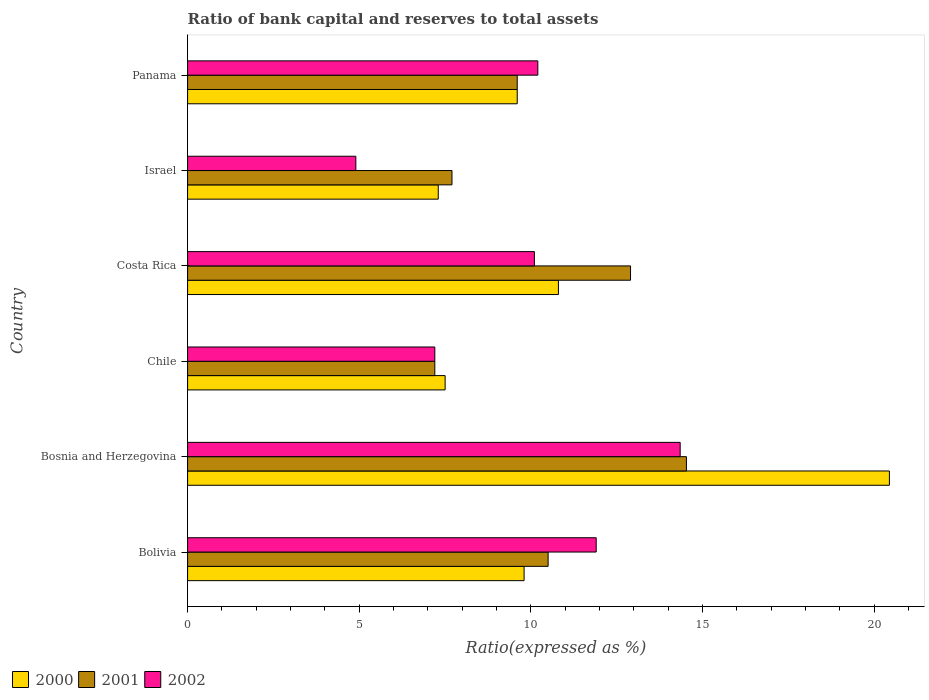Are the number of bars per tick equal to the number of legend labels?
Provide a succinct answer. Yes. How many bars are there on the 2nd tick from the top?
Offer a very short reply. 3. How many bars are there on the 5th tick from the bottom?
Offer a very short reply. 3. What is the label of the 6th group of bars from the top?
Your answer should be very brief. Bolivia. What is the ratio of bank capital and reserves to total assets in 2000 in Chile?
Make the answer very short. 7.5. Across all countries, what is the maximum ratio of bank capital and reserves to total assets in 2000?
Give a very brief answer. 20.44. In which country was the ratio of bank capital and reserves to total assets in 2001 maximum?
Provide a succinct answer. Bosnia and Herzegovina. In which country was the ratio of bank capital and reserves to total assets in 2001 minimum?
Ensure brevity in your answer.  Chile. What is the total ratio of bank capital and reserves to total assets in 2001 in the graph?
Your answer should be compact. 62.43. What is the difference between the ratio of bank capital and reserves to total assets in 2001 in Bolivia and the ratio of bank capital and reserves to total assets in 2002 in Chile?
Provide a succinct answer. 3.3. What is the average ratio of bank capital and reserves to total assets in 2000 per country?
Your response must be concise. 10.91. What is the difference between the ratio of bank capital and reserves to total assets in 2001 and ratio of bank capital and reserves to total assets in 2000 in Costa Rica?
Ensure brevity in your answer.  2.1. What is the ratio of the ratio of bank capital and reserves to total assets in 2002 in Bolivia to that in Chile?
Ensure brevity in your answer.  1.65. Is the ratio of bank capital and reserves to total assets in 2000 in Chile less than that in Panama?
Make the answer very short. Yes. What is the difference between the highest and the second highest ratio of bank capital and reserves to total assets in 2002?
Your answer should be compact. 2.45. What is the difference between the highest and the lowest ratio of bank capital and reserves to total assets in 2002?
Ensure brevity in your answer.  9.45. In how many countries, is the ratio of bank capital and reserves to total assets in 2000 greater than the average ratio of bank capital and reserves to total assets in 2000 taken over all countries?
Give a very brief answer. 1. Is the sum of the ratio of bank capital and reserves to total assets in 2001 in Chile and Costa Rica greater than the maximum ratio of bank capital and reserves to total assets in 2002 across all countries?
Give a very brief answer. Yes. What does the 3rd bar from the bottom in Panama represents?
Provide a succinct answer. 2002. Are all the bars in the graph horizontal?
Your answer should be very brief. Yes. How many countries are there in the graph?
Provide a succinct answer. 6. Are the values on the major ticks of X-axis written in scientific E-notation?
Give a very brief answer. No. Does the graph contain any zero values?
Provide a succinct answer. No. How are the legend labels stacked?
Provide a succinct answer. Horizontal. What is the title of the graph?
Provide a short and direct response. Ratio of bank capital and reserves to total assets. What is the label or title of the X-axis?
Your response must be concise. Ratio(expressed as %). What is the Ratio(expressed as %) in 2000 in Bolivia?
Offer a very short reply. 9.8. What is the Ratio(expressed as %) of 2001 in Bolivia?
Keep it short and to the point. 10.5. What is the Ratio(expressed as %) of 2002 in Bolivia?
Make the answer very short. 11.9. What is the Ratio(expressed as %) in 2000 in Bosnia and Herzegovina?
Ensure brevity in your answer.  20.44. What is the Ratio(expressed as %) in 2001 in Bosnia and Herzegovina?
Keep it short and to the point. 14.53. What is the Ratio(expressed as %) in 2002 in Bosnia and Herzegovina?
Your answer should be compact. 14.35. What is the Ratio(expressed as %) in 2002 in Chile?
Make the answer very short. 7.2. What is the Ratio(expressed as %) in 2000 in Costa Rica?
Your answer should be very brief. 10.8. What is the Ratio(expressed as %) of 2001 in Costa Rica?
Provide a succinct answer. 12.9. What is the Ratio(expressed as %) in 2000 in Israel?
Your response must be concise. 7.3. What is the Ratio(expressed as %) of 2000 in Panama?
Offer a terse response. 9.6. What is the Ratio(expressed as %) in 2001 in Panama?
Offer a very short reply. 9.6. What is the Ratio(expressed as %) in 2002 in Panama?
Your response must be concise. 10.2. Across all countries, what is the maximum Ratio(expressed as %) of 2000?
Provide a succinct answer. 20.44. Across all countries, what is the maximum Ratio(expressed as %) in 2001?
Offer a terse response. 14.53. Across all countries, what is the maximum Ratio(expressed as %) of 2002?
Make the answer very short. 14.35. Across all countries, what is the minimum Ratio(expressed as %) of 2000?
Offer a very short reply. 7.3. Across all countries, what is the minimum Ratio(expressed as %) in 2001?
Provide a short and direct response. 7.2. Across all countries, what is the minimum Ratio(expressed as %) of 2002?
Your answer should be very brief. 4.9. What is the total Ratio(expressed as %) of 2000 in the graph?
Your response must be concise. 65.44. What is the total Ratio(expressed as %) in 2001 in the graph?
Give a very brief answer. 62.43. What is the total Ratio(expressed as %) of 2002 in the graph?
Make the answer very short. 58.65. What is the difference between the Ratio(expressed as %) in 2000 in Bolivia and that in Bosnia and Herzegovina?
Keep it short and to the point. -10.64. What is the difference between the Ratio(expressed as %) in 2001 in Bolivia and that in Bosnia and Herzegovina?
Ensure brevity in your answer.  -4.03. What is the difference between the Ratio(expressed as %) in 2002 in Bolivia and that in Bosnia and Herzegovina?
Make the answer very short. -2.45. What is the difference between the Ratio(expressed as %) of 2000 in Bolivia and that in Chile?
Offer a terse response. 2.3. What is the difference between the Ratio(expressed as %) of 2000 in Bolivia and that in Costa Rica?
Keep it short and to the point. -1. What is the difference between the Ratio(expressed as %) in 2000 in Bolivia and that in Israel?
Your answer should be very brief. 2.5. What is the difference between the Ratio(expressed as %) of 2000 in Bolivia and that in Panama?
Offer a terse response. 0.2. What is the difference between the Ratio(expressed as %) of 2001 in Bolivia and that in Panama?
Offer a very short reply. 0.9. What is the difference between the Ratio(expressed as %) in 2002 in Bolivia and that in Panama?
Keep it short and to the point. 1.7. What is the difference between the Ratio(expressed as %) in 2000 in Bosnia and Herzegovina and that in Chile?
Make the answer very short. 12.94. What is the difference between the Ratio(expressed as %) in 2001 in Bosnia and Herzegovina and that in Chile?
Your answer should be compact. 7.33. What is the difference between the Ratio(expressed as %) of 2002 in Bosnia and Herzegovina and that in Chile?
Your response must be concise. 7.15. What is the difference between the Ratio(expressed as %) in 2000 in Bosnia and Herzegovina and that in Costa Rica?
Ensure brevity in your answer.  9.64. What is the difference between the Ratio(expressed as %) of 2001 in Bosnia and Herzegovina and that in Costa Rica?
Offer a terse response. 1.63. What is the difference between the Ratio(expressed as %) in 2002 in Bosnia and Herzegovina and that in Costa Rica?
Your response must be concise. 4.25. What is the difference between the Ratio(expressed as %) in 2000 in Bosnia and Herzegovina and that in Israel?
Offer a very short reply. 13.14. What is the difference between the Ratio(expressed as %) of 2001 in Bosnia and Herzegovina and that in Israel?
Offer a very short reply. 6.83. What is the difference between the Ratio(expressed as %) in 2002 in Bosnia and Herzegovina and that in Israel?
Your answer should be very brief. 9.45. What is the difference between the Ratio(expressed as %) in 2000 in Bosnia and Herzegovina and that in Panama?
Provide a succinct answer. 10.84. What is the difference between the Ratio(expressed as %) of 2001 in Bosnia and Herzegovina and that in Panama?
Provide a short and direct response. 4.93. What is the difference between the Ratio(expressed as %) in 2002 in Bosnia and Herzegovina and that in Panama?
Ensure brevity in your answer.  4.15. What is the difference between the Ratio(expressed as %) in 2000 in Chile and that in Costa Rica?
Your response must be concise. -3.3. What is the difference between the Ratio(expressed as %) in 2000 in Chile and that in Panama?
Give a very brief answer. -2.1. What is the difference between the Ratio(expressed as %) of 2001 in Chile and that in Panama?
Make the answer very short. -2.4. What is the difference between the Ratio(expressed as %) of 2002 in Chile and that in Panama?
Ensure brevity in your answer.  -3. What is the difference between the Ratio(expressed as %) of 2000 in Israel and that in Panama?
Make the answer very short. -2.3. What is the difference between the Ratio(expressed as %) in 2001 in Israel and that in Panama?
Your answer should be compact. -1.9. What is the difference between the Ratio(expressed as %) of 2002 in Israel and that in Panama?
Provide a short and direct response. -5.3. What is the difference between the Ratio(expressed as %) of 2000 in Bolivia and the Ratio(expressed as %) of 2001 in Bosnia and Herzegovina?
Make the answer very short. -4.73. What is the difference between the Ratio(expressed as %) of 2000 in Bolivia and the Ratio(expressed as %) of 2002 in Bosnia and Herzegovina?
Keep it short and to the point. -4.55. What is the difference between the Ratio(expressed as %) of 2001 in Bolivia and the Ratio(expressed as %) of 2002 in Bosnia and Herzegovina?
Make the answer very short. -3.85. What is the difference between the Ratio(expressed as %) of 2000 in Bolivia and the Ratio(expressed as %) of 2001 in Chile?
Ensure brevity in your answer.  2.6. What is the difference between the Ratio(expressed as %) of 2001 in Bolivia and the Ratio(expressed as %) of 2002 in Chile?
Keep it short and to the point. 3.3. What is the difference between the Ratio(expressed as %) of 2000 in Bolivia and the Ratio(expressed as %) of 2002 in Costa Rica?
Provide a short and direct response. -0.3. What is the difference between the Ratio(expressed as %) of 2001 in Bolivia and the Ratio(expressed as %) of 2002 in Costa Rica?
Your response must be concise. 0.4. What is the difference between the Ratio(expressed as %) of 2000 in Bolivia and the Ratio(expressed as %) of 2001 in Israel?
Offer a terse response. 2.1. What is the difference between the Ratio(expressed as %) in 2001 in Bolivia and the Ratio(expressed as %) in 2002 in Panama?
Provide a short and direct response. 0.3. What is the difference between the Ratio(expressed as %) in 2000 in Bosnia and Herzegovina and the Ratio(expressed as %) in 2001 in Chile?
Your answer should be very brief. 13.24. What is the difference between the Ratio(expressed as %) in 2000 in Bosnia and Herzegovina and the Ratio(expressed as %) in 2002 in Chile?
Your response must be concise. 13.24. What is the difference between the Ratio(expressed as %) of 2001 in Bosnia and Herzegovina and the Ratio(expressed as %) of 2002 in Chile?
Offer a terse response. 7.33. What is the difference between the Ratio(expressed as %) in 2000 in Bosnia and Herzegovina and the Ratio(expressed as %) in 2001 in Costa Rica?
Provide a short and direct response. 7.54. What is the difference between the Ratio(expressed as %) of 2000 in Bosnia and Herzegovina and the Ratio(expressed as %) of 2002 in Costa Rica?
Keep it short and to the point. 10.34. What is the difference between the Ratio(expressed as %) in 2001 in Bosnia and Herzegovina and the Ratio(expressed as %) in 2002 in Costa Rica?
Your response must be concise. 4.43. What is the difference between the Ratio(expressed as %) of 2000 in Bosnia and Herzegovina and the Ratio(expressed as %) of 2001 in Israel?
Ensure brevity in your answer.  12.74. What is the difference between the Ratio(expressed as %) in 2000 in Bosnia and Herzegovina and the Ratio(expressed as %) in 2002 in Israel?
Offer a very short reply. 15.54. What is the difference between the Ratio(expressed as %) in 2001 in Bosnia and Herzegovina and the Ratio(expressed as %) in 2002 in Israel?
Ensure brevity in your answer.  9.63. What is the difference between the Ratio(expressed as %) of 2000 in Bosnia and Herzegovina and the Ratio(expressed as %) of 2001 in Panama?
Your response must be concise. 10.84. What is the difference between the Ratio(expressed as %) in 2000 in Bosnia and Herzegovina and the Ratio(expressed as %) in 2002 in Panama?
Your response must be concise. 10.24. What is the difference between the Ratio(expressed as %) of 2001 in Bosnia and Herzegovina and the Ratio(expressed as %) of 2002 in Panama?
Make the answer very short. 4.33. What is the difference between the Ratio(expressed as %) in 2000 in Chile and the Ratio(expressed as %) in 2001 in Costa Rica?
Ensure brevity in your answer.  -5.4. What is the difference between the Ratio(expressed as %) in 2000 in Chile and the Ratio(expressed as %) in 2002 in Panama?
Your answer should be very brief. -2.7. What is the difference between the Ratio(expressed as %) in 2000 in Costa Rica and the Ratio(expressed as %) in 2002 in Israel?
Keep it short and to the point. 5.9. What is the difference between the Ratio(expressed as %) of 2001 in Costa Rica and the Ratio(expressed as %) of 2002 in Israel?
Your answer should be very brief. 8. What is the difference between the Ratio(expressed as %) in 2001 in Costa Rica and the Ratio(expressed as %) in 2002 in Panama?
Give a very brief answer. 2.7. What is the difference between the Ratio(expressed as %) in 2000 in Israel and the Ratio(expressed as %) in 2001 in Panama?
Provide a short and direct response. -2.3. What is the difference between the Ratio(expressed as %) of 2000 in Israel and the Ratio(expressed as %) of 2002 in Panama?
Make the answer very short. -2.9. What is the average Ratio(expressed as %) of 2000 per country?
Provide a short and direct response. 10.91. What is the average Ratio(expressed as %) of 2001 per country?
Give a very brief answer. 10.4. What is the average Ratio(expressed as %) of 2002 per country?
Provide a short and direct response. 9.77. What is the difference between the Ratio(expressed as %) of 2001 and Ratio(expressed as %) of 2002 in Bolivia?
Your response must be concise. -1.4. What is the difference between the Ratio(expressed as %) in 2000 and Ratio(expressed as %) in 2001 in Bosnia and Herzegovina?
Ensure brevity in your answer.  5.91. What is the difference between the Ratio(expressed as %) in 2000 and Ratio(expressed as %) in 2002 in Bosnia and Herzegovina?
Provide a short and direct response. 6.09. What is the difference between the Ratio(expressed as %) in 2001 and Ratio(expressed as %) in 2002 in Bosnia and Herzegovina?
Provide a succinct answer. 0.18. What is the difference between the Ratio(expressed as %) of 2000 and Ratio(expressed as %) of 2001 in Chile?
Your response must be concise. 0.3. What is the difference between the Ratio(expressed as %) in 2000 and Ratio(expressed as %) in 2001 in Costa Rica?
Provide a succinct answer. -2.1. What is the difference between the Ratio(expressed as %) in 2000 and Ratio(expressed as %) in 2002 in Costa Rica?
Ensure brevity in your answer.  0.7. What is the difference between the Ratio(expressed as %) of 2000 and Ratio(expressed as %) of 2001 in Israel?
Provide a succinct answer. -0.4. What is the difference between the Ratio(expressed as %) of 2000 and Ratio(expressed as %) of 2002 in Israel?
Your response must be concise. 2.4. What is the difference between the Ratio(expressed as %) of 2000 and Ratio(expressed as %) of 2001 in Panama?
Give a very brief answer. 0. What is the difference between the Ratio(expressed as %) in 2001 and Ratio(expressed as %) in 2002 in Panama?
Offer a very short reply. -0.6. What is the ratio of the Ratio(expressed as %) in 2000 in Bolivia to that in Bosnia and Herzegovina?
Give a very brief answer. 0.48. What is the ratio of the Ratio(expressed as %) of 2001 in Bolivia to that in Bosnia and Herzegovina?
Give a very brief answer. 0.72. What is the ratio of the Ratio(expressed as %) in 2002 in Bolivia to that in Bosnia and Herzegovina?
Offer a terse response. 0.83. What is the ratio of the Ratio(expressed as %) in 2000 in Bolivia to that in Chile?
Make the answer very short. 1.31. What is the ratio of the Ratio(expressed as %) in 2001 in Bolivia to that in Chile?
Your answer should be compact. 1.46. What is the ratio of the Ratio(expressed as %) in 2002 in Bolivia to that in Chile?
Offer a terse response. 1.65. What is the ratio of the Ratio(expressed as %) in 2000 in Bolivia to that in Costa Rica?
Keep it short and to the point. 0.91. What is the ratio of the Ratio(expressed as %) in 2001 in Bolivia to that in Costa Rica?
Ensure brevity in your answer.  0.81. What is the ratio of the Ratio(expressed as %) in 2002 in Bolivia to that in Costa Rica?
Offer a terse response. 1.18. What is the ratio of the Ratio(expressed as %) in 2000 in Bolivia to that in Israel?
Keep it short and to the point. 1.34. What is the ratio of the Ratio(expressed as %) of 2001 in Bolivia to that in Israel?
Your answer should be compact. 1.36. What is the ratio of the Ratio(expressed as %) in 2002 in Bolivia to that in Israel?
Keep it short and to the point. 2.43. What is the ratio of the Ratio(expressed as %) of 2000 in Bolivia to that in Panama?
Give a very brief answer. 1.02. What is the ratio of the Ratio(expressed as %) of 2001 in Bolivia to that in Panama?
Your answer should be compact. 1.09. What is the ratio of the Ratio(expressed as %) of 2002 in Bolivia to that in Panama?
Make the answer very short. 1.17. What is the ratio of the Ratio(expressed as %) of 2000 in Bosnia and Herzegovina to that in Chile?
Make the answer very short. 2.73. What is the ratio of the Ratio(expressed as %) of 2001 in Bosnia and Herzegovina to that in Chile?
Give a very brief answer. 2.02. What is the ratio of the Ratio(expressed as %) in 2002 in Bosnia and Herzegovina to that in Chile?
Offer a terse response. 1.99. What is the ratio of the Ratio(expressed as %) in 2000 in Bosnia and Herzegovina to that in Costa Rica?
Your answer should be very brief. 1.89. What is the ratio of the Ratio(expressed as %) in 2001 in Bosnia and Herzegovina to that in Costa Rica?
Provide a short and direct response. 1.13. What is the ratio of the Ratio(expressed as %) of 2002 in Bosnia and Herzegovina to that in Costa Rica?
Offer a very short reply. 1.42. What is the ratio of the Ratio(expressed as %) of 2000 in Bosnia and Herzegovina to that in Israel?
Offer a terse response. 2.8. What is the ratio of the Ratio(expressed as %) in 2001 in Bosnia and Herzegovina to that in Israel?
Your response must be concise. 1.89. What is the ratio of the Ratio(expressed as %) of 2002 in Bosnia and Herzegovina to that in Israel?
Offer a very short reply. 2.93. What is the ratio of the Ratio(expressed as %) of 2000 in Bosnia and Herzegovina to that in Panama?
Your answer should be compact. 2.13. What is the ratio of the Ratio(expressed as %) in 2001 in Bosnia and Herzegovina to that in Panama?
Ensure brevity in your answer.  1.51. What is the ratio of the Ratio(expressed as %) of 2002 in Bosnia and Herzegovina to that in Panama?
Keep it short and to the point. 1.41. What is the ratio of the Ratio(expressed as %) in 2000 in Chile to that in Costa Rica?
Make the answer very short. 0.69. What is the ratio of the Ratio(expressed as %) of 2001 in Chile to that in Costa Rica?
Give a very brief answer. 0.56. What is the ratio of the Ratio(expressed as %) in 2002 in Chile to that in Costa Rica?
Offer a very short reply. 0.71. What is the ratio of the Ratio(expressed as %) in 2000 in Chile to that in Israel?
Offer a terse response. 1.03. What is the ratio of the Ratio(expressed as %) of 2001 in Chile to that in Israel?
Your answer should be compact. 0.94. What is the ratio of the Ratio(expressed as %) in 2002 in Chile to that in Israel?
Keep it short and to the point. 1.47. What is the ratio of the Ratio(expressed as %) of 2000 in Chile to that in Panama?
Your answer should be very brief. 0.78. What is the ratio of the Ratio(expressed as %) of 2001 in Chile to that in Panama?
Provide a short and direct response. 0.75. What is the ratio of the Ratio(expressed as %) of 2002 in Chile to that in Panama?
Offer a terse response. 0.71. What is the ratio of the Ratio(expressed as %) in 2000 in Costa Rica to that in Israel?
Keep it short and to the point. 1.48. What is the ratio of the Ratio(expressed as %) in 2001 in Costa Rica to that in Israel?
Offer a very short reply. 1.68. What is the ratio of the Ratio(expressed as %) of 2002 in Costa Rica to that in Israel?
Provide a short and direct response. 2.06. What is the ratio of the Ratio(expressed as %) of 2000 in Costa Rica to that in Panama?
Give a very brief answer. 1.12. What is the ratio of the Ratio(expressed as %) of 2001 in Costa Rica to that in Panama?
Your response must be concise. 1.34. What is the ratio of the Ratio(expressed as %) in 2002 in Costa Rica to that in Panama?
Offer a very short reply. 0.99. What is the ratio of the Ratio(expressed as %) of 2000 in Israel to that in Panama?
Offer a terse response. 0.76. What is the ratio of the Ratio(expressed as %) of 2001 in Israel to that in Panama?
Offer a terse response. 0.8. What is the ratio of the Ratio(expressed as %) of 2002 in Israel to that in Panama?
Provide a succinct answer. 0.48. What is the difference between the highest and the second highest Ratio(expressed as %) in 2000?
Make the answer very short. 9.64. What is the difference between the highest and the second highest Ratio(expressed as %) of 2001?
Provide a succinct answer. 1.63. What is the difference between the highest and the second highest Ratio(expressed as %) in 2002?
Ensure brevity in your answer.  2.45. What is the difference between the highest and the lowest Ratio(expressed as %) of 2000?
Provide a succinct answer. 13.14. What is the difference between the highest and the lowest Ratio(expressed as %) in 2001?
Offer a terse response. 7.33. What is the difference between the highest and the lowest Ratio(expressed as %) of 2002?
Your answer should be compact. 9.45. 